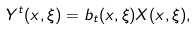Convert formula to latex. <formula><loc_0><loc_0><loc_500><loc_500>Y ^ { t } ( x , \xi ) = b _ { t } ( x , \xi ) X ( x , \xi ) ,</formula> 